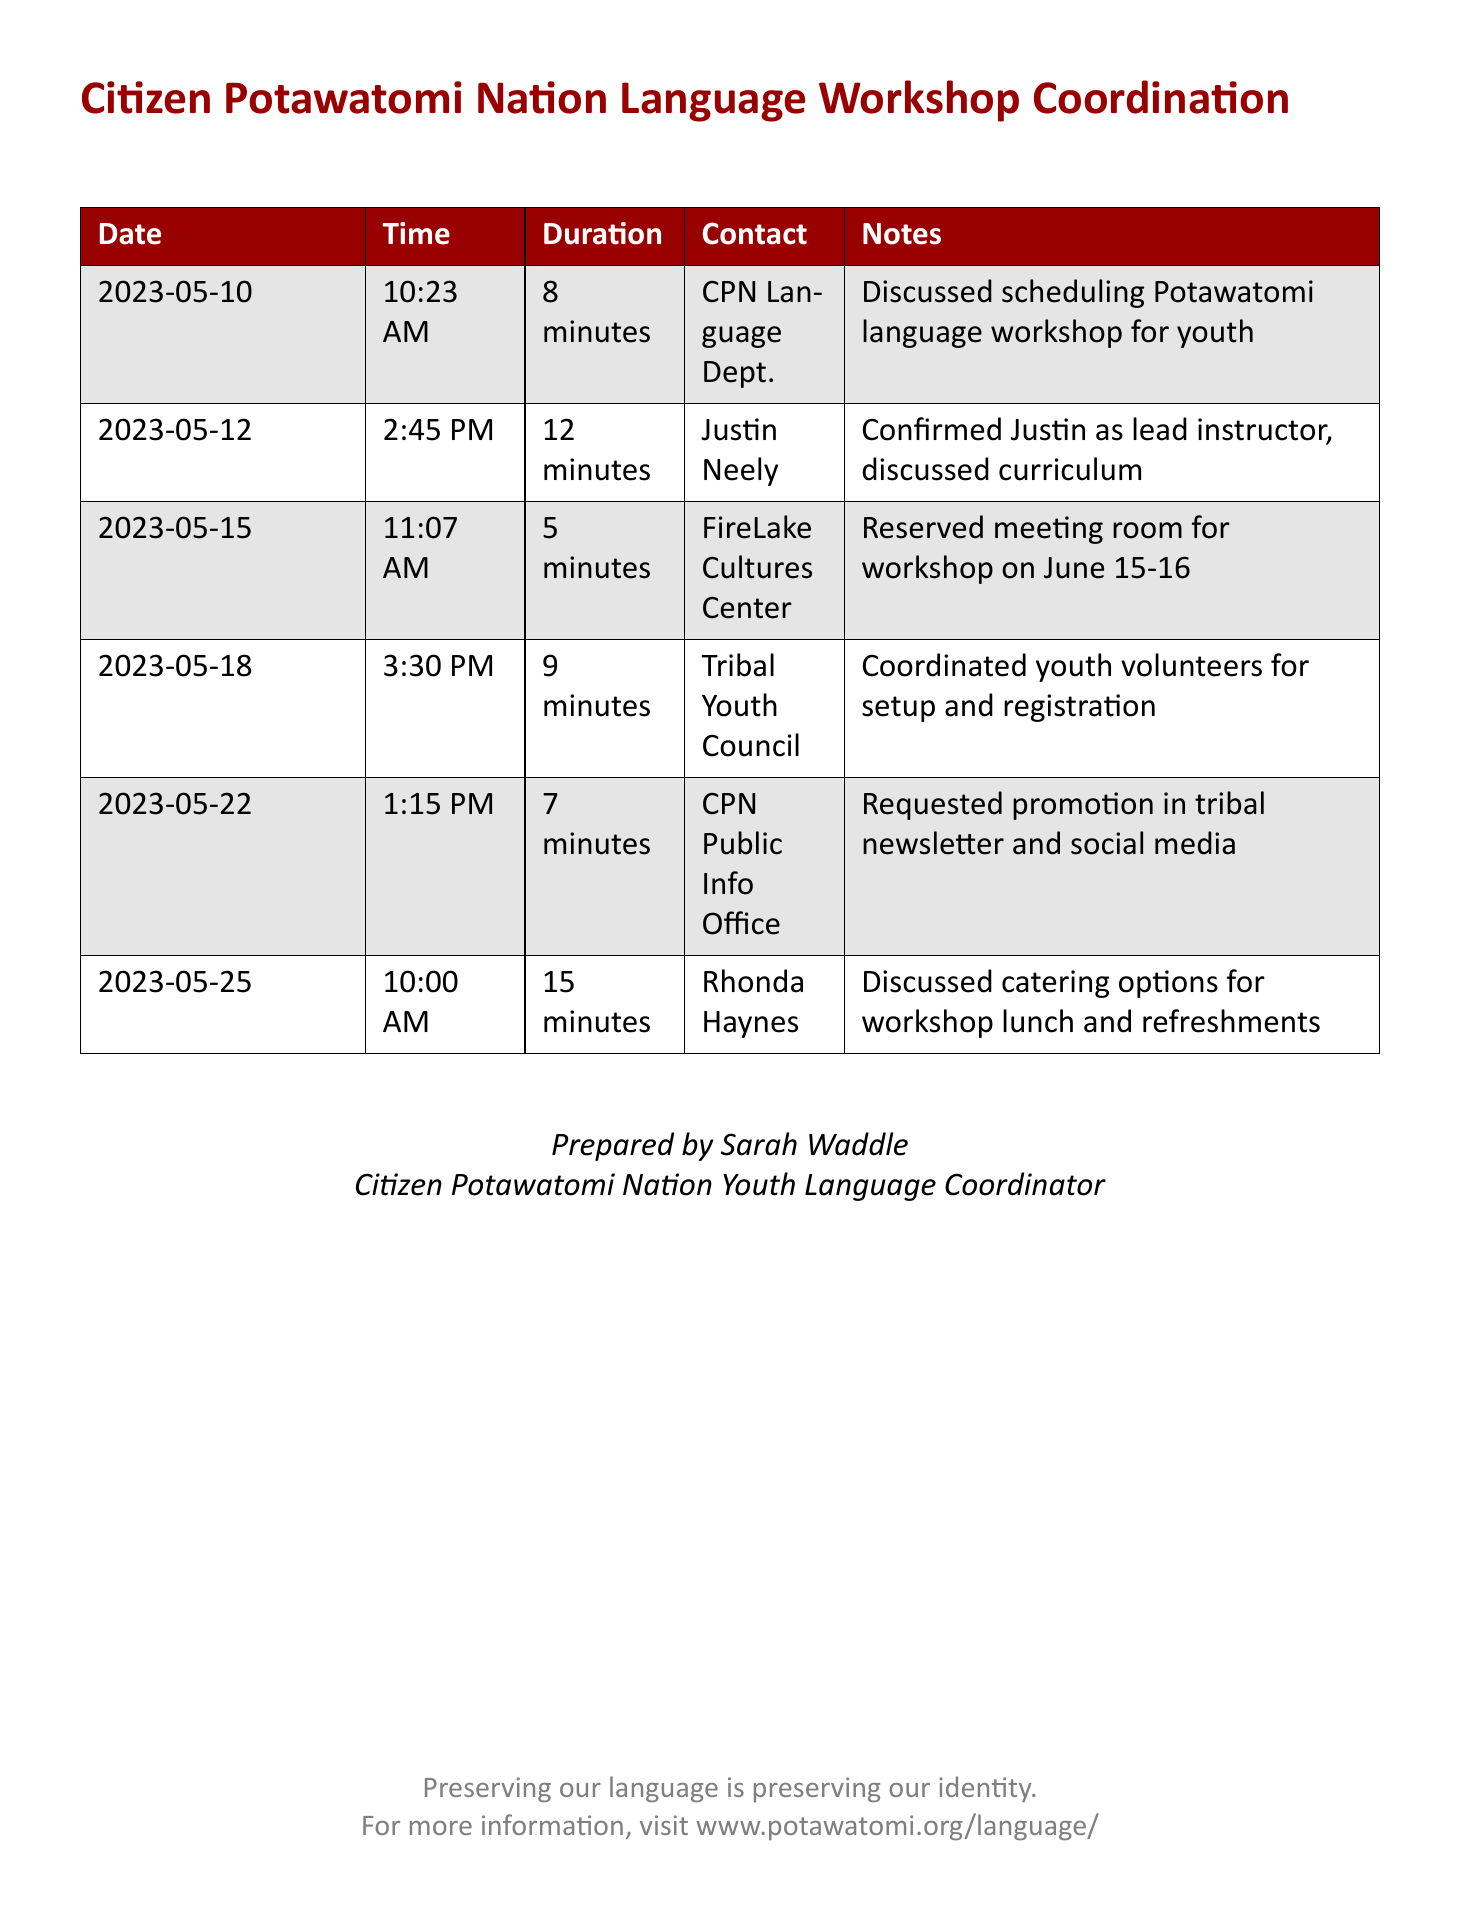what is the start date of the workshop? The workshop is scheduled for June 15-16, which can be found in the telephone records regarding the reserved meeting room.
Answer: June 15-16 who is the lead instructor for the workshop? Justin Neely is confirmed as the lead instructor, as stated in the conversation recorded on May 12.
Answer: Justin Neely how long was the conversation with the Tribal Youth Council? The duration of the call on May 18 was 9 minutes, as indicated in the records.
Answer: 9 minutes what did the CPN Public Info Office provide for the workshop? The document mentions a request for promotion in the tribal newsletter and social media, reflecting their support for the workshop.
Answer: Promotion how many minutes did the call with Rhonda Haynes last? The duration of the call with Rhonda Haynes on May 25 is noted as 15 minutes in the document.
Answer: 15 minutes which department did the first call involve? The call on May 10 was with the CPN Language Department, as indicated in the records.
Answer: CPN Language Dept what was discussed during the call on May 22? The call with the CPN Public Info Office revolved around requesting promotion, providing insight into the communication's purpose.
Answer: Promotion how many minutes long was the call to confirm Justin Neely? The conversation confirming Justin as the lead instructor lasted 12 minutes, showing the time allocation for discussion.
Answer: 12 minutes 